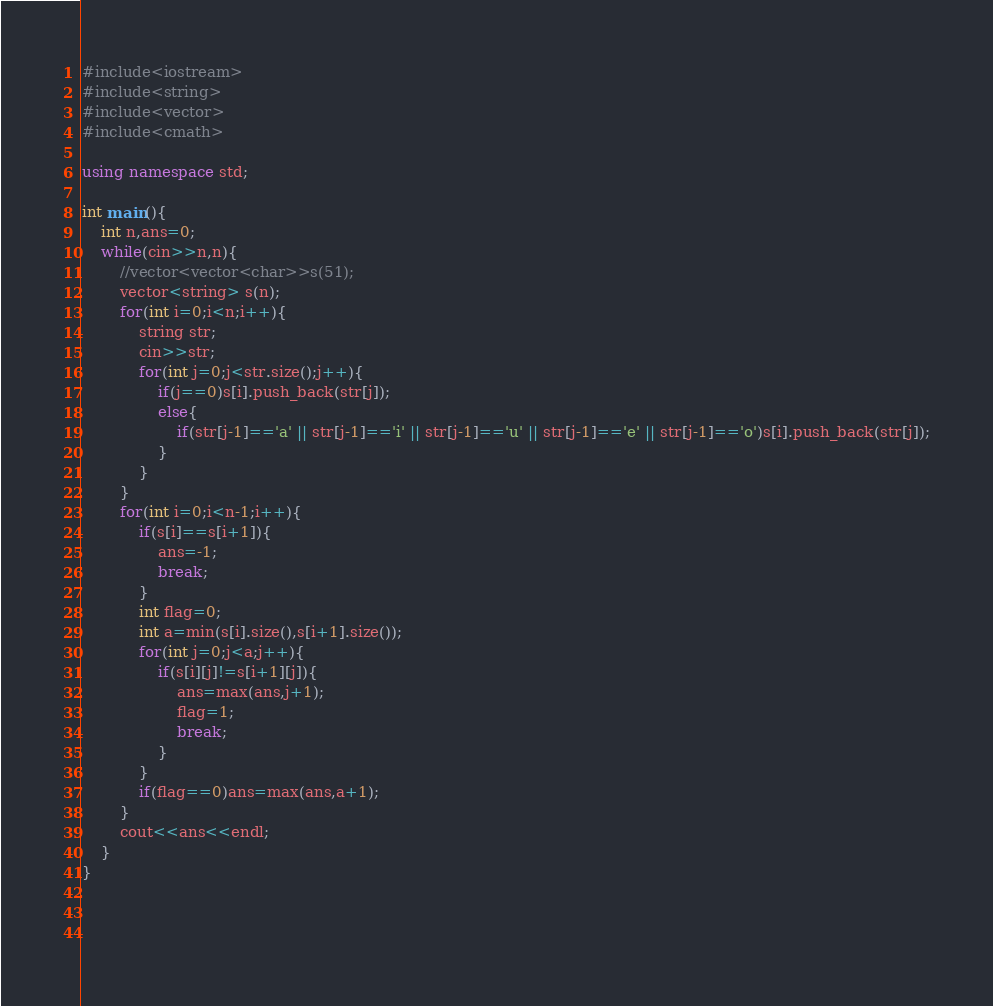<code> <loc_0><loc_0><loc_500><loc_500><_C++_>#include<iostream>
#include<string>
#include<vector>
#include<cmath>

using namespace std;

int main(){
    int n,ans=0;
    while(cin>>n,n){
        //vector<vector<char>>s(51);
        vector<string> s(n);
        for(int i=0;i<n;i++){
            string str;
            cin>>str;
            for(int j=0;j<str.size();j++){
                if(j==0)s[i].push_back(str[j]);
                else{
                    if(str[j-1]=='a' || str[j-1]=='i' || str[j-1]=='u' || str[j-1]=='e' || str[j-1]=='o')s[i].push_back(str[j]);
                }
            }
        }
        for(int i=0;i<n-1;i++){
            if(s[i]==s[i+1]){
                ans=-1;
                break;
            }
            int flag=0;
            int a=min(s[i].size(),s[i+1].size());
            for(int j=0;j<a;j++){
                if(s[i][j]!=s[i+1][j]){
                    ans=max(ans,j+1);
                    flag=1;
                    break;
                }
            }
            if(flag==0)ans=max(ans,a+1);
        }
        cout<<ans<<endl;
    }
}

            
            </code> 